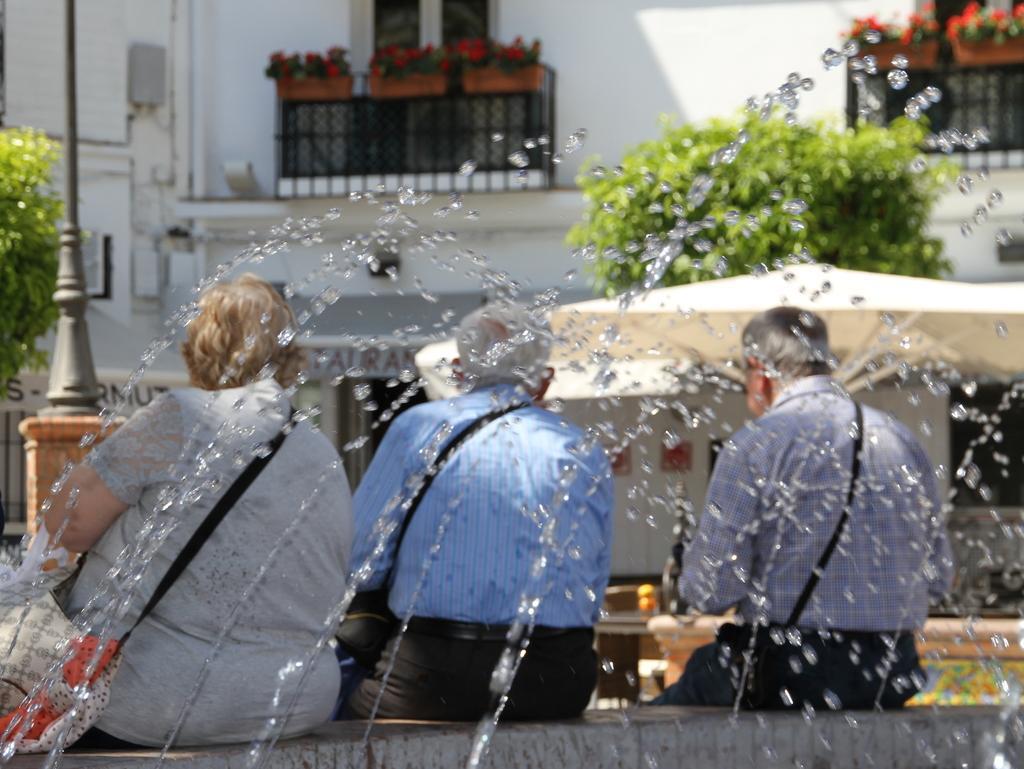Could you give a brief overview of what you see in this image? In the image we can see three people sitting and they are facing back, they are wearing clothes and carrying bags. Here we can see water drips, poles, plants, flower plants and the background is blurred. 